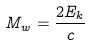<formula> <loc_0><loc_0><loc_500><loc_500>M _ { w } = \frac { 2 E _ { k } } { c }</formula> 